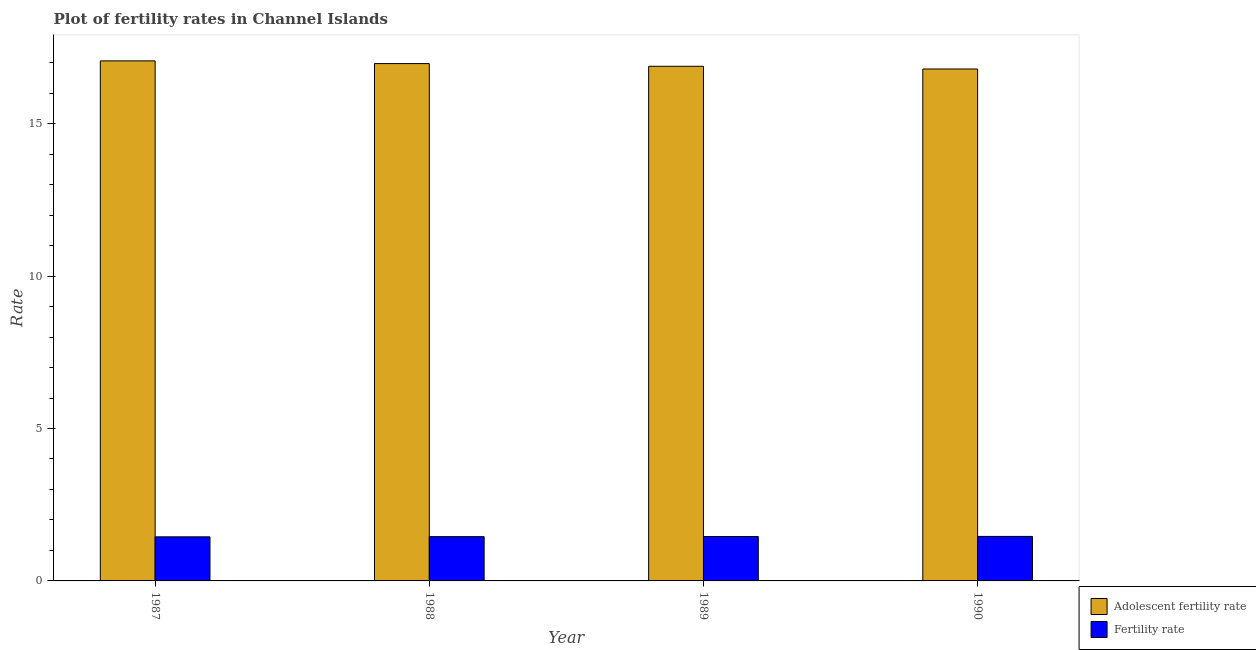Are the number of bars per tick equal to the number of legend labels?
Keep it short and to the point. Yes. What is the label of the 1st group of bars from the left?
Offer a terse response. 1987. In how many cases, is the number of bars for a given year not equal to the number of legend labels?
Your answer should be compact. 0. What is the fertility rate in 1987?
Make the answer very short. 1.45. Across all years, what is the maximum adolescent fertility rate?
Your response must be concise. 17.06. Across all years, what is the minimum adolescent fertility rate?
Offer a terse response. 16.79. In which year was the adolescent fertility rate maximum?
Offer a very short reply. 1987. In which year was the adolescent fertility rate minimum?
Your response must be concise. 1990. What is the total fertility rate in the graph?
Your answer should be compact. 5.81. What is the difference between the adolescent fertility rate in 1989 and that in 1990?
Your answer should be compact. 0.09. What is the difference between the adolescent fertility rate in 1987 and the fertility rate in 1989?
Ensure brevity in your answer.  0.18. What is the average fertility rate per year?
Provide a succinct answer. 1.45. What is the ratio of the fertility rate in 1988 to that in 1989?
Offer a very short reply. 1. Is the fertility rate in 1987 less than that in 1988?
Provide a short and direct response. Yes. Is the difference between the adolescent fertility rate in 1987 and 1990 greater than the difference between the fertility rate in 1987 and 1990?
Your response must be concise. No. What is the difference between the highest and the second highest adolescent fertility rate?
Offer a very short reply. 0.09. What is the difference between the highest and the lowest fertility rate?
Ensure brevity in your answer.  0.01. In how many years, is the fertility rate greater than the average fertility rate taken over all years?
Your answer should be very brief. 2. What does the 2nd bar from the left in 1988 represents?
Provide a short and direct response. Fertility rate. What does the 1st bar from the right in 1990 represents?
Give a very brief answer. Fertility rate. How many years are there in the graph?
Your response must be concise. 4. What is the difference between two consecutive major ticks on the Y-axis?
Your answer should be compact. 5. Does the graph contain any zero values?
Make the answer very short. No. Where does the legend appear in the graph?
Offer a terse response. Bottom right. How are the legend labels stacked?
Offer a terse response. Vertical. What is the title of the graph?
Provide a short and direct response. Plot of fertility rates in Channel Islands. What is the label or title of the Y-axis?
Provide a succinct answer. Rate. What is the Rate in Adolescent fertility rate in 1987?
Provide a short and direct response. 17.06. What is the Rate in Fertility rate in 1987?
Offer a very short reply. 1.45. What is the Rate of Adolescent fertility rate in 1988?
Give a very brief answer. 16.97. What is the Rate of Fertility rate in 1988?
Your answer should be compact. 1.45. What is the Rate of Adolescent fertility rate in 1989?
Provide a short and direct response. 16.88. What is the Rate in Fertility rate in 1989?
Offer a terse response. 1.46. What is the Rate of Adolescent fertility rate in 1990?
Give a very brief answer. 16.79. What is the Rate in Fertility rate in 1990?
Your answer should be very brief. 1.46. Across all years, what is the maximum Rate in Adolescent fertility rate?
Offer a terse response. 17.06. Across all years, what is the maximum Rate of Fertility rate?
Give a very brief answer. 1.46. Across all years, what is the minimum Rate of Adolescent fertility rate?
Keep it short and to the point. 16.79. Across all years, what is the minimum Rate in Fertility rate?
Ensure brevity in your answer.  1.45. What is the total Rate in Adolescent fertility rate in the graph?
Your answer should be very brief. 67.7. What is the total Rate in Fertility rate in the graph?
Your response must be concise. 5.82. What is the difference between the Rate of Adolescent fertility rate in 1987 and that in 1988?
Your answer should be very brief. 0.09. What is the difference between the Rate in Fertility rate in 1987 and that in 1988?
Your response must be concise. -0.01. What is the difference between the Rate of Adolescent fertility rate in 1987 and that in 1989?
Offer a terse response. 0.18. What is the difference between the Rate of Fertility rate in 1987 and that in 1989?
Your answer should be compact. -0.01. What is the difference between the Rate of Adolescent fertility rate in 1987 and that in 1990?
Offer a very short reply. 0.27. What is the difference between the Rate of Fertility rate in 1987 and that in 1990?
Provide a short and direct response. -0.01. What is the difference between the Rate in Adolescent fertility rate in 1988 and that in 1989?
Provide a succinct answer. 0.09. What is the difference between the Rate in Fertility rate in 1988 and that in 1989?
Offer a terse response. -0.01. What is the difference between the Rate of Adolescent fertility rate in 1988 and that in 1990?
Your answer should be compact. 0.18. What is the difference between the Rate of Fertility rate in 1988 and that in 1990?
Your response must be concise. -0.01. What is the difference between the Rate in Adolescent fertility rate in 1989 and that in 1990?
Ensure brevity in your answer.  0.09. What is the difference between the Rate in Fertility rate in 1989 and that in 1990?
Offer a very short reply. -0. What is the difference between the Rate of Adolescent fertility rate in 1987 and the Rate of Fertility rate in 1988?
Your response must be concise. 15.61. What is the difference between the Rate in Adolescent fertility rate in 1987 and the Rate in Fertility rate in 1989?
Provide a succinct answer. 15.6. What is the difference between the Rate in Adolescent fertility rate in 1987 and the Rate in Fertility rate in 1990?
Keep it short and to the point. 15.6. What is the difference between the Rate of Adolescent fertility rate in 1988 and the Rate of Fertility rate in 1989?
Keep it short and to the point. 15.51. What is the difference between the Rate of Adolescent fertility rate in 1988 and the Rate of Fertility rate in 1990?
Give a very brief answer. 15.51. What is the difference between the Rate of Adolescent fertility rate in 1989 and the Rate of Fertility rate in 1990?
Provide a succinct answer. 15.42. What is the average Rate of Adolescent fertility rate per year?
Offer a very short reply. 16.92. What is the average Rate of Fertility rate per year?
Provide a succinct answer. 1.45. In the year 1987, what is the difference between the Rate of Adolescent fertility rate and Rate of Fertility rate?
Your response must be concise. 15.61. In the year 1988, what is the difference between the Rate of Adolescent fertility rate and Rate of Fertility rate?
Your answer should be compact. 15.52. In the year 1989, what is the difference between the Rate of Adolescent fertility rate and Rate of Fertility rate?
Offer a terse response. 15.42. In the year 1990, what is the difference between the Rate of Adolescent fertility rate and Rate of Fertility rate?
Offer a very short reply. 15.33. What is the ratio of the Rate in Adolescent fertility rate in 1987 to that in 1989?
Give a very brief answer. 1.01. What is the ratio of the Rate of Fertility rate in 1987 to that in 1989?
Your response must be concise. 0.99. What is the ratio of the Rate of Adolescent fertility rate in 1987 to that in 1990?
Offer a very short reply. 1.02. What is the ratio of the Rate in Fertility rate in 1987 to that in 1990?
Your answer should be very brief. 0.99. What is the ratio of the Rate in Fertility rate in 1988 to that in 1989?
Keep it short and to the point. 1. What is the ratio of the Rate of Adolescent fertility rate in 1988 to that in 1990?
Ensure brevity in your answer.  1.01. What is the difference between the highest and the second highest Rate of Adolescent fertility rate?
Ensure brevity in your answer.  0.09. What is the difference between the highest and the second highest Rate of Fertility rate?
Your answer should be very brief. 0. What is the difference between the highest and the lowest Rate of Adolescent fertility rate?
Ensure brevity in your answer.  0.27. What is the difference between the highest and the lowest Rate in Fertility rate?
Your answer should be compact. 0.01. 